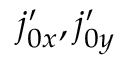<formula> <loc_0><loc_0><loc_500><loc_500>{ j _ { 0 x } ^ { \prime } } , { j _ { 0 y } ^ { \prime } }</formula> 